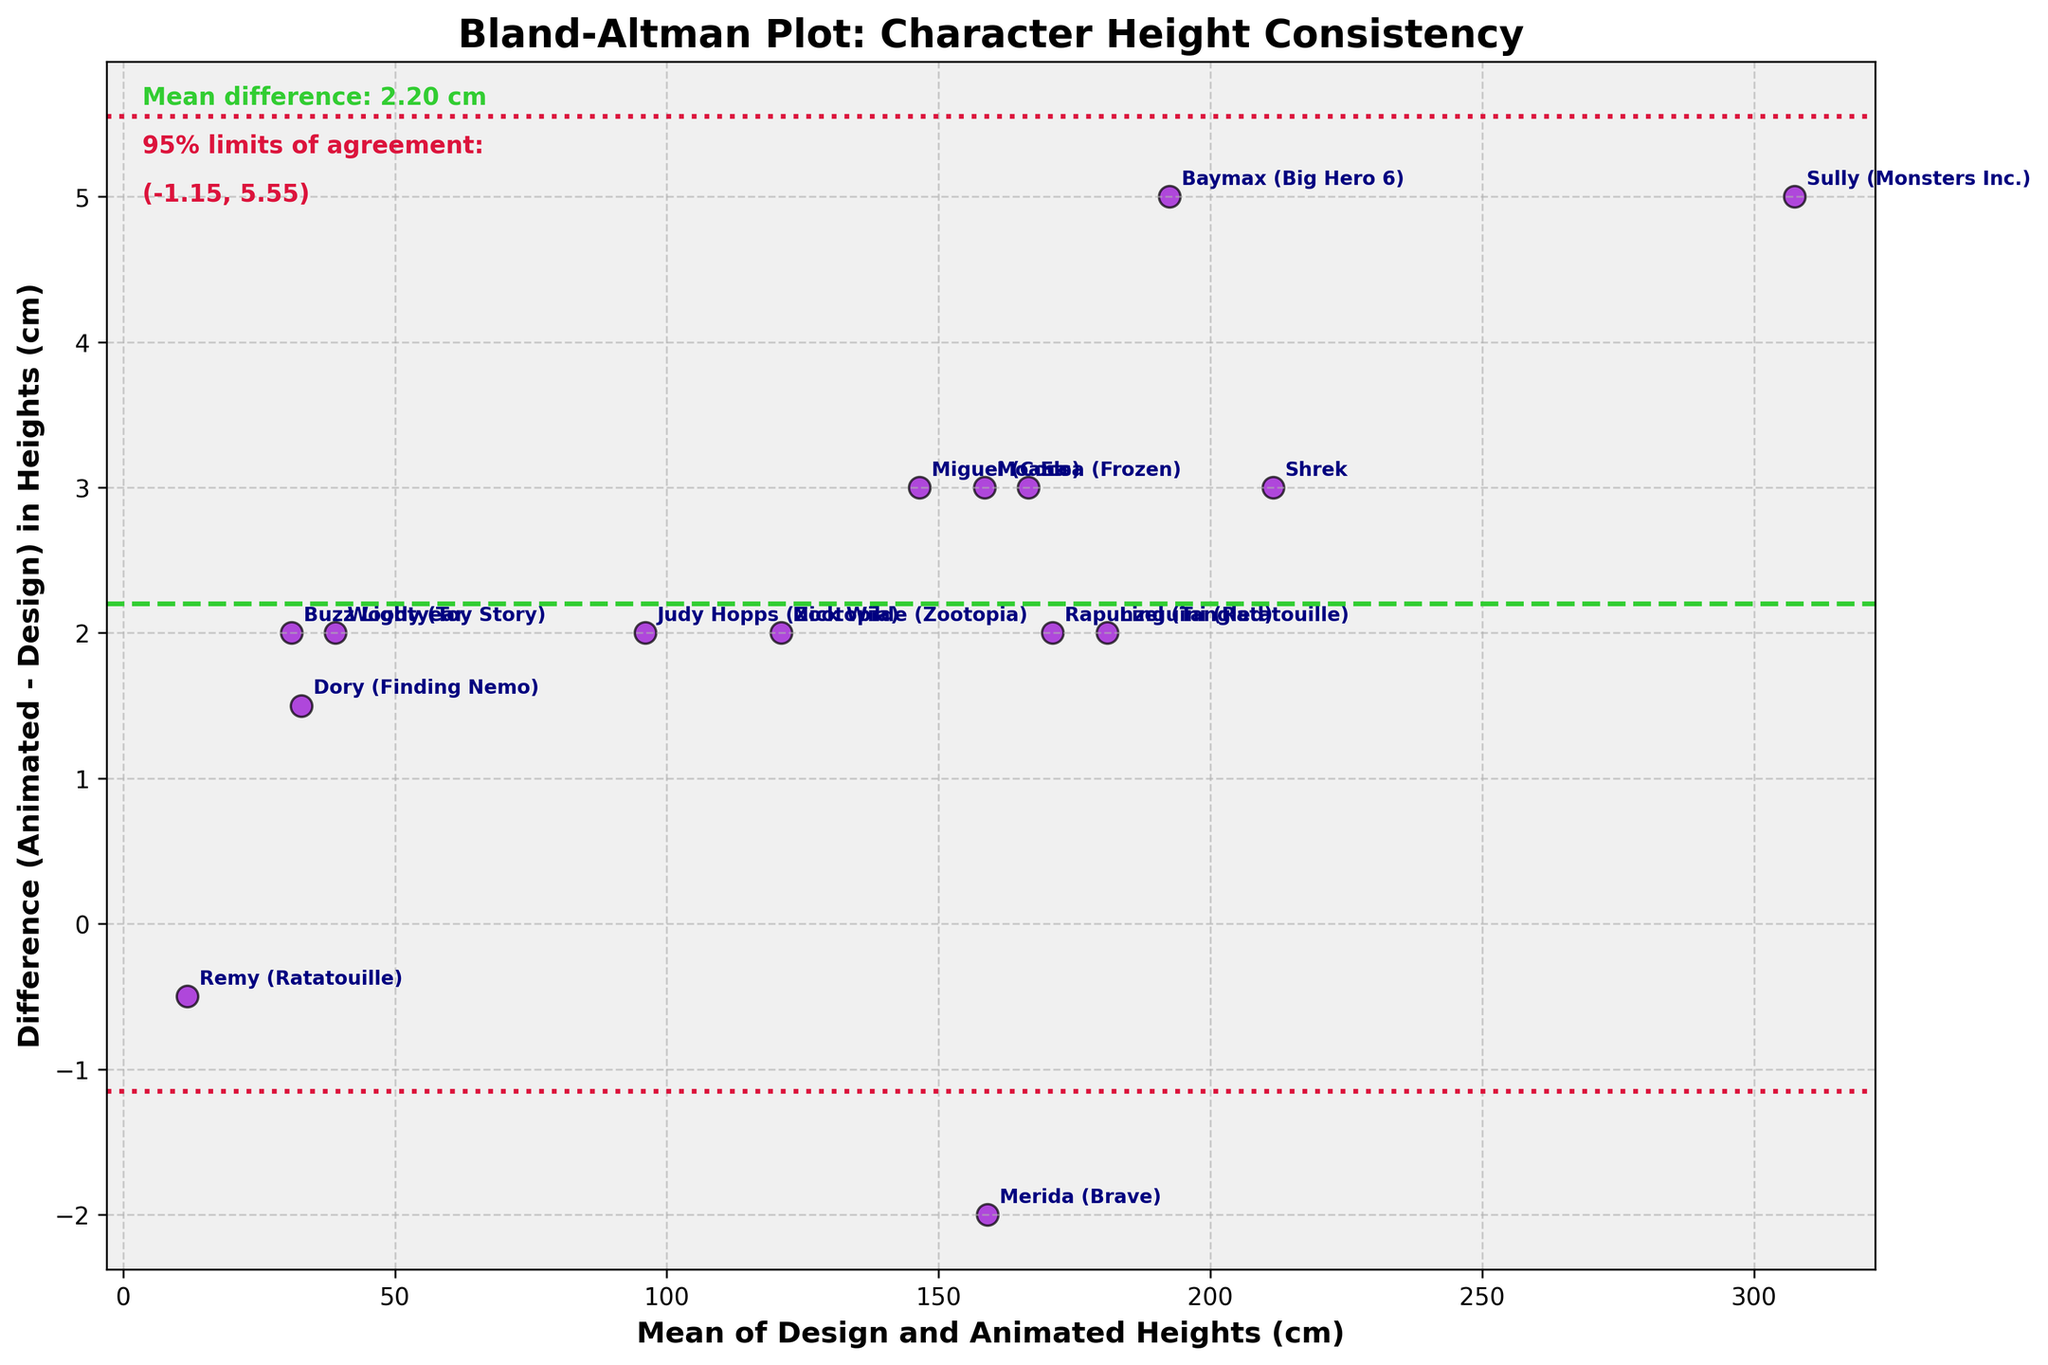What is the title of the plot? The title of a plot is typically displayed at the top of the figure, providing a summary of what the plot represents. Here, the title "Bland-Altman Plot: Character Height Consistency" is clearly shown at the top.
Answer: Bland-Altman Plot: Character Height Consistency What do the green and red lines represent on the plot? The green dashed line represents the mean difference between the design and animated heights. The red dotted lines represent the 95% limits of agreement, which are calculated as the mean difference ± 1.96 times the standard deviation of the differences.
Answer: Green line: mean difference; Red lines: 95% limits of agreement What is the mean difference in heights between the design and animated models? The mean difference is calculated by averaging the differences between each pair of design and animated heights. This value is indicated by the green dashed line and is also annotated on the plot as "Mean difference: 1.87 cm".
Answer: 1.87 cm Which character has the largest positive difference between the design and animated heights? The character with the largest positive difference is identified by locating the point farthest above the x-axis (mean height line). Sully stands out as the character with the largest positive difference of approximately 5 cm.
Answer: Sully How wide are the 95% limits of agreement? The width of the 95% limits of agreement can be calculated as the difference between the upper and lower red dotted lines. The values are annotated on the plot as (mean difference ± 1.96*standard deviation), so the calculation is 1.87 ± ~2.60, totaling ~5.20 cm.
Answer: ~5.20 cm Which characters have a negative difference between design and animated heights? Characters with negative differences will have points positioned below the x-axis (mean height line). Merida and Remy appear below this line, indicating their animated heights are shorter than the design heights.
Answer: Merida, Remy What is the average mean height of Elsa and Moana in the plot? The average mean height of Elsa and Moana can be found by summing their mean heights [(165+168)/2 for Elsa and (157+160)/2 for Moana] and then averaging these two results. The calculated mean heights are 166.5 cm and 158.5 cm respectively, so the average mean height is (166.5 + 158.5)/2 = 162.5 cm.
Answer: 162.5 cm Which character is the closest to having no difference in height between design and animated models? Points closest to the x-axis indicate minimal difference between design and animated heights. Merida's point lies closest to this line, suggesting the smallest absolute difference.
Answer: Merida Is Buzz Lightyear taller or shorter in the animated model compared to the design? By observing the plot, Buzz Lightyear's point is positioned above the x-axis (mean height line), indicating his animated height is greater than his design height.
Answer: Taller How many characters have mean heights greater than 150 cm? To find this, count the number of points to the right of the 150 cm mark on the x-axis. Characters with mean heights greater than 150 cm include Elsa, Moana, Shrek, Merida, Rapunzel, Miguel, Baymax, Linguini, and Nick Wilde. There are 9 such characters.
Answer: 9 